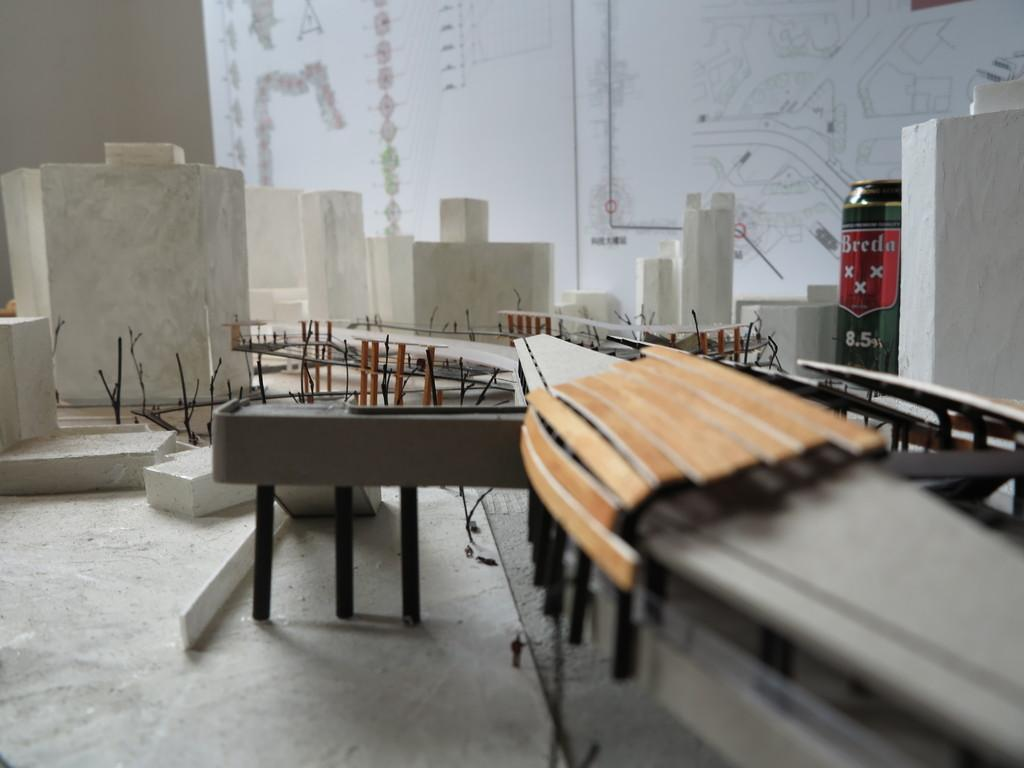What is the main subject of the image? The image appears to depict a table. What can be seen on the table? There is a tin on the table. What type of material is present in the image? There are marble stones in the image. What kind of artwork is featured in the image? There is a poster with pencil art in the image. How many bikes are parked near the table in the image? There are no bikes present in the image. What type of attraction can be seen in the background of the image? There is no attraction visible in the image; it only features a table, a tin, marble stones, and a poster with pencil art. 